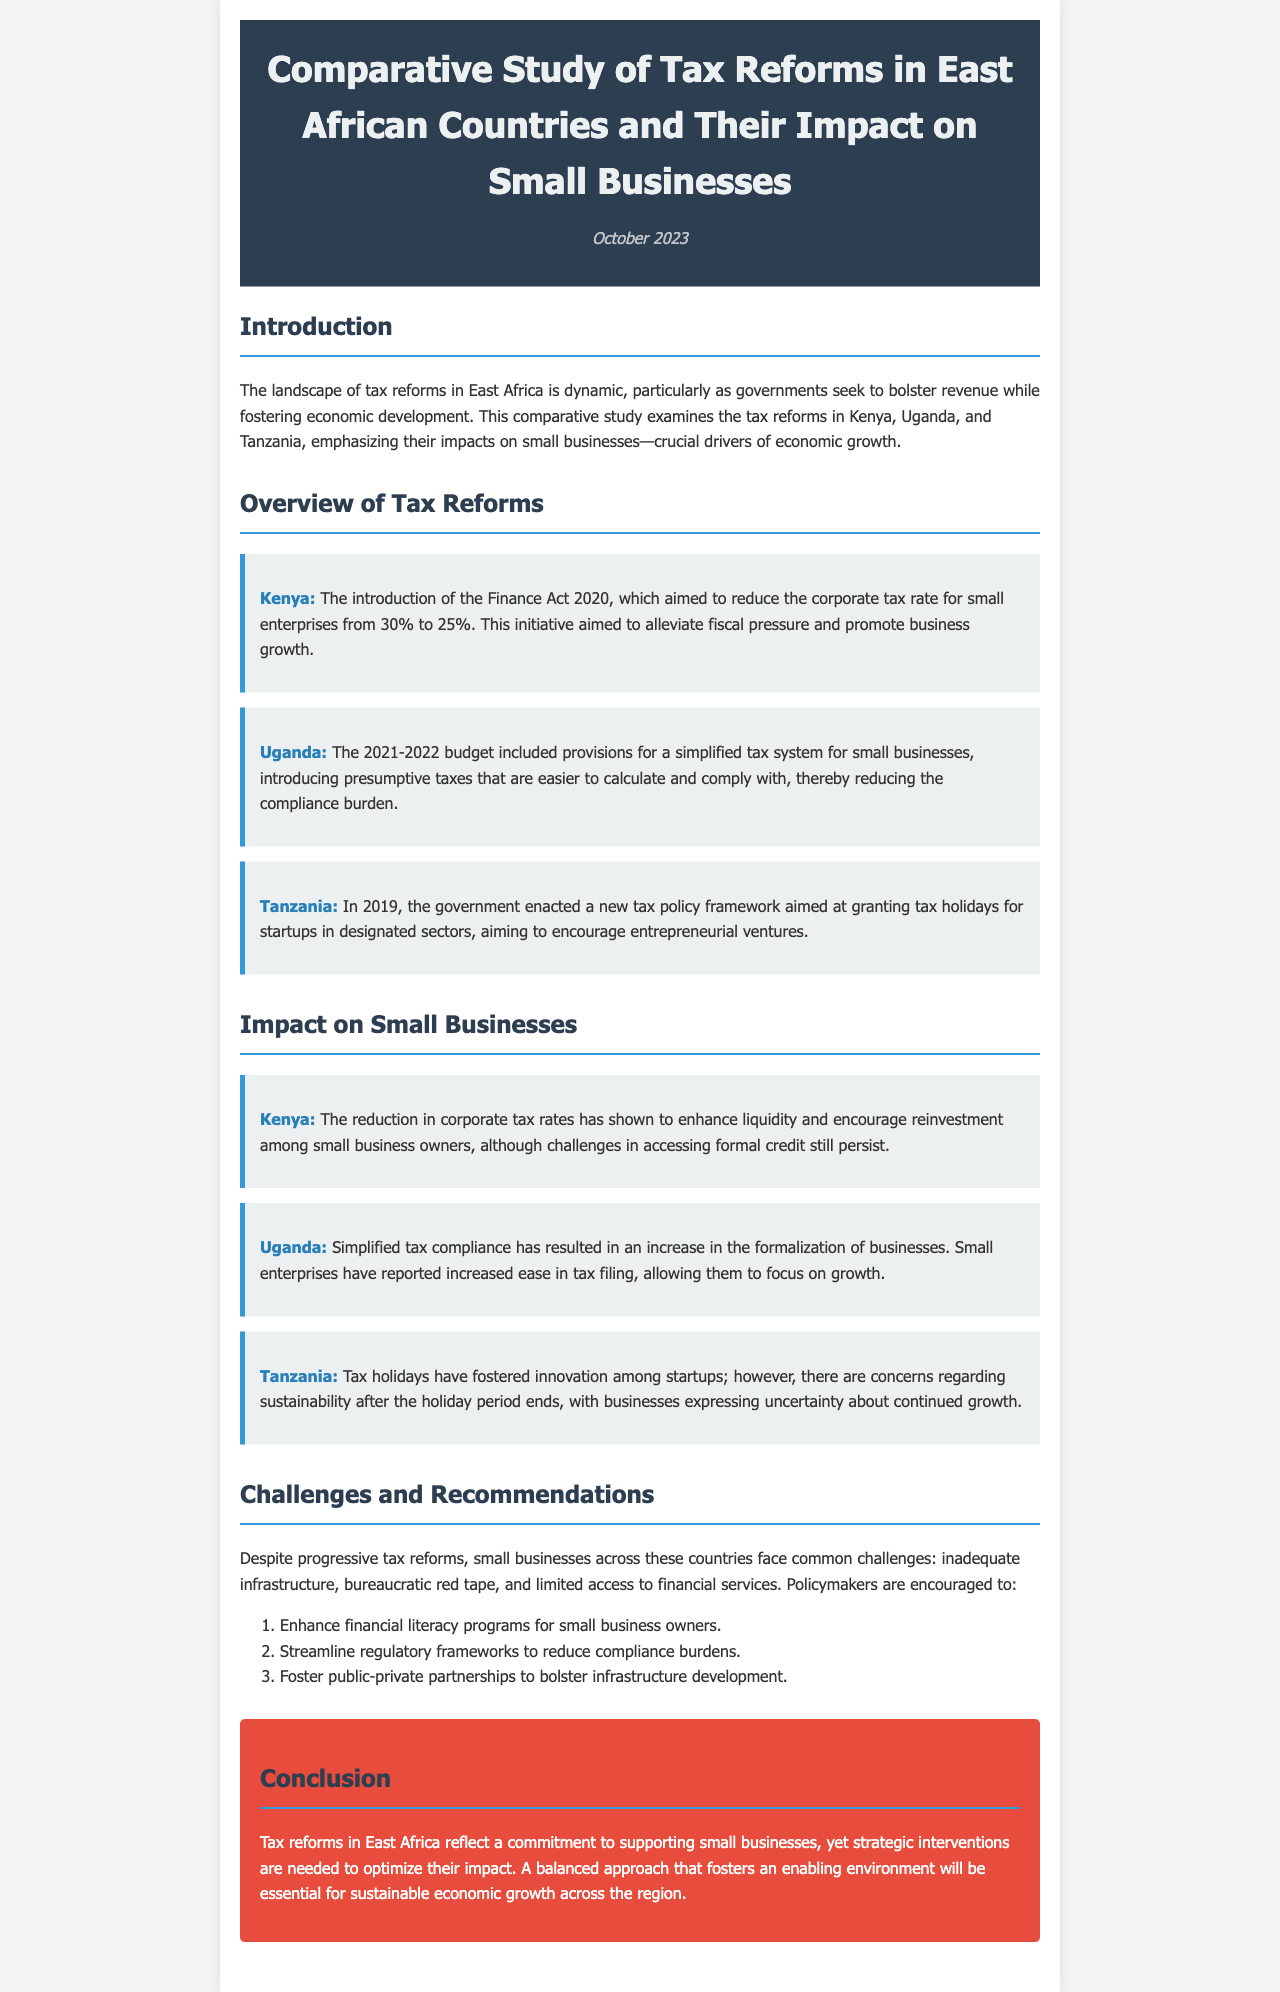What is the title of the newsletter? The title can be found in the header section of the document.
Answer: Comparative Study of Tax Reforms in East African Countries and Their Impact on Small Businesses What year did Kenya reduce the corporate tax rate for small enterprises? The information is found in the overview of tax reforms section regarding Kenya.
Answer: 2020 What type of tax system was introduced in Uganda's 2021-2022 budget? This information is detailed under the overview of tax reforms section for Uganda.
Answer: Simplified tax system What benefit did Tanzania's tax policy provide for startups? This is stated in the overview section under Tanzania's description.
Answer: Tax holidays What has simplified tax compliance in Uganda resulted in? The impact on small businesses in Uganda is discussed in the impact section.
Answer: Increase in formalization of businesses Name one challenge faced by small businesses in East Africa. This is mentioned in the challenges and recommendations section.
Answer: Inadequate infrastructure What is one recommendation for policymakers mentioned in the document? The recommendations provided are detailed in the challenges and recommendations section.
Answer: Enhance financial literacy programs for small business owners What is the primary focus of this newsletter? The introduction section clarifies the main aim of the study.
Answer: Tax reforms and their impact on small businesses 